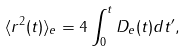<formula> <loc_0><loc_0><loc_500><loc_500>\langle { r } ^ { 2 } ( t ) \rangle _ { e } = 4 \int ^ { t } _ { 0 } D _ { e } ( t ) d t ^ { \prime } ,</formula> 